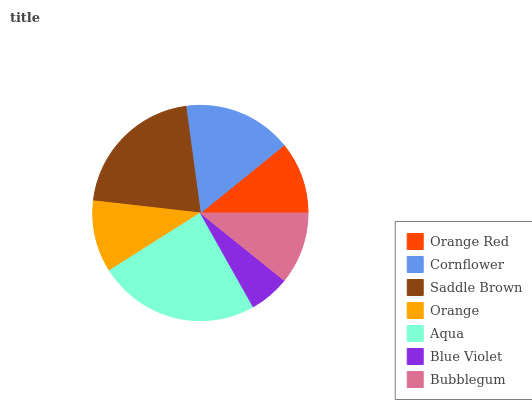Is Blue Violet the minimum?
Answer yes or no. Yes. Is Aqua the maximum?
Answer yes or no. Yes. Is Cornflower the minimum?
Answer yes or no. No. Is Cornflower the maximum?
Answer yes or no. No. Is Cornflower greater than Orange Red?
Answer yes or no. Yes. Is Orange Red less than Cornflower?
Answer yes or no. Yes. Is Orange Red greater than Cornflower?
Answer yes or no. No. Is Cornflower less than Orange Red?
Answer yes or no. No. Is Orange Red the high median?
Answer yes or no. Yes. Is Orange Red the low median?
Answer yes or no. Yes. Is Orange the high median?
Answer yes or no. No. Is Orange the low median?
Answer yes or no. No. 